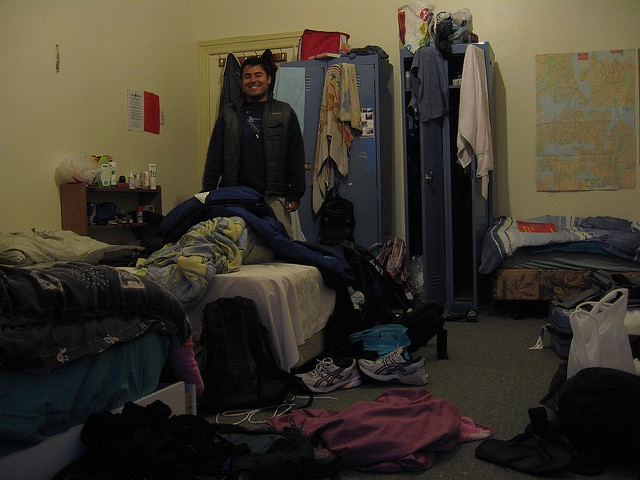Describe the objects in this image and their specific colors. I can see bed in olive, black, darkgreen, and gray tones, bed in olive, black, darkgreen, and gray tones, bed in olive, black, gray, and maroon tones, people in olive, black, gray, and maroon tones, and backpack in olive, black, gray, darkgreen, and maroon tones in this image. 